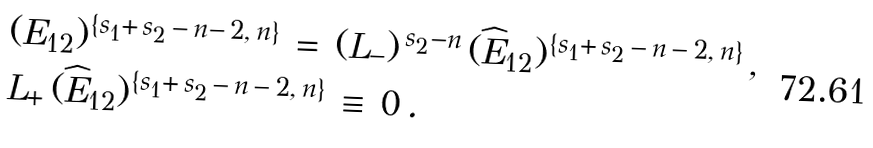<formula> <loc_0><loc_0><loc_500><loc_500>& ( E _ { 1 2 } ) ^ { \{ s _ { 1 } + \, s _ { 2 } \, - \, n - \, 2 , \, n \} } \, = \, ( L _ { - } ) ^ { \, s _ { 2 } - n } \, ( \widehat { E } _ { 1 2 } ) ^ { \{ s _ { 1 } + \, s _ { 2 } \, - \, n \, - \, 2 , \, n \} } \, , \\ & L _ { + } \, ( \widehat { E } _ { 1 2 } ) ^ { \{ s _ { 1 } + \, s _ { 2 } \, - \, n \, - \, 2 , \, n \} } \, \equiv \, 0 \, .</formula> 